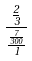Convert formula to latex. <formula><loc_0><loc_0><loc_500><loc_500>\frac { \frac { 2 } { 3 } } { \frac { \frac { 7 } { 3 0 0 } } { 1 } }</formula> 